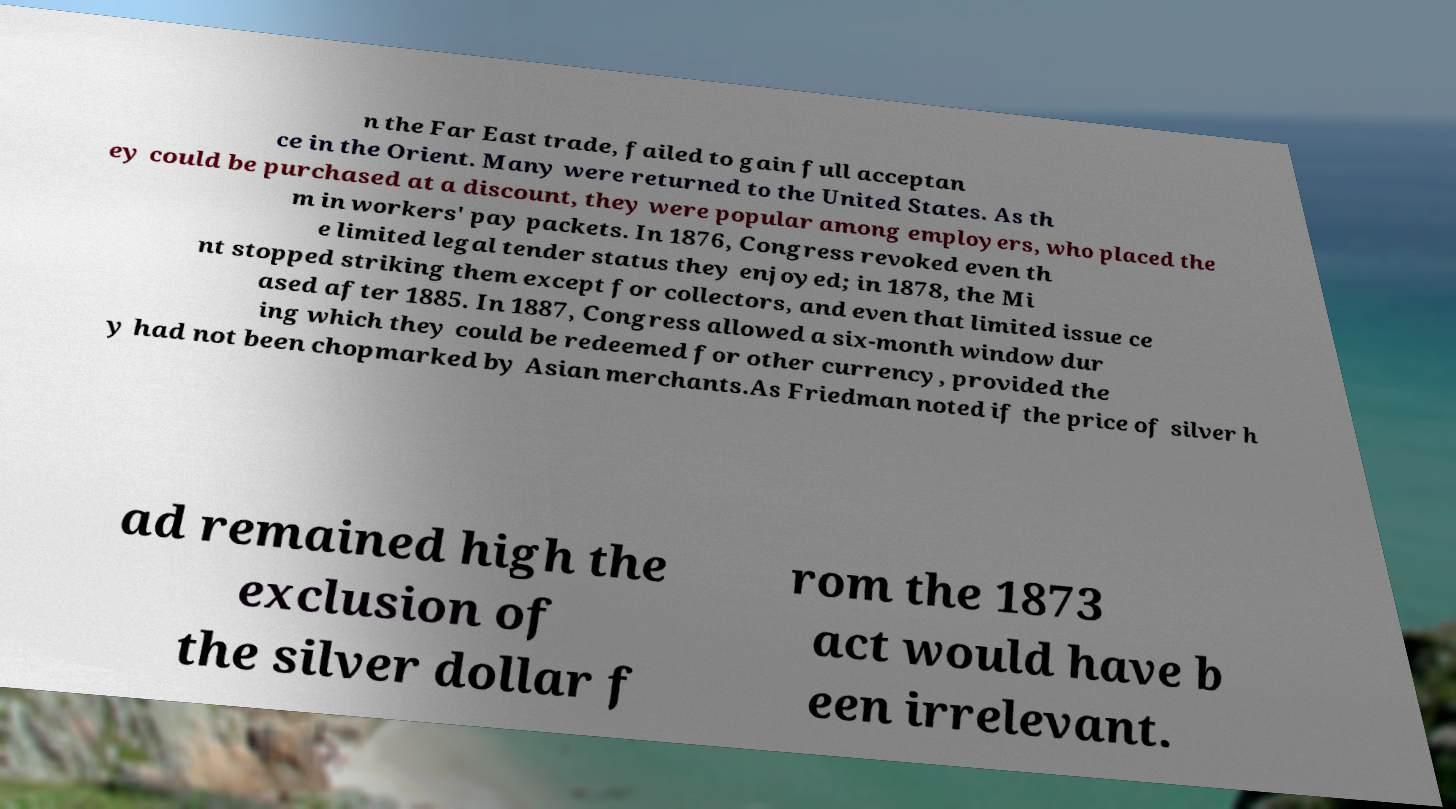Please identify and transcribe the text found in this image. n the Far East trade, failed to gain full acceptan ce in the Orient. Many were returned to the United States. As th ey could be purchased at a discount, they were popular among employers, who placed the m in workers' pay packets. In 1876, Congress revoked even th e limited legal tender status they enjoyed; in 1878, the Mi nt stopped striking them except for collectors, and even that limited issue ce ased after 1885. In 1887, Congress allowed a six-month window dur ing which they could be redeemed for other currency, provided the y had not been chopmarked by Asian merchants.As Friedman noted if the price of silver h ad remained high the exclusion of the silver dollar f rom the 1873 act would have b een irrelevant. 